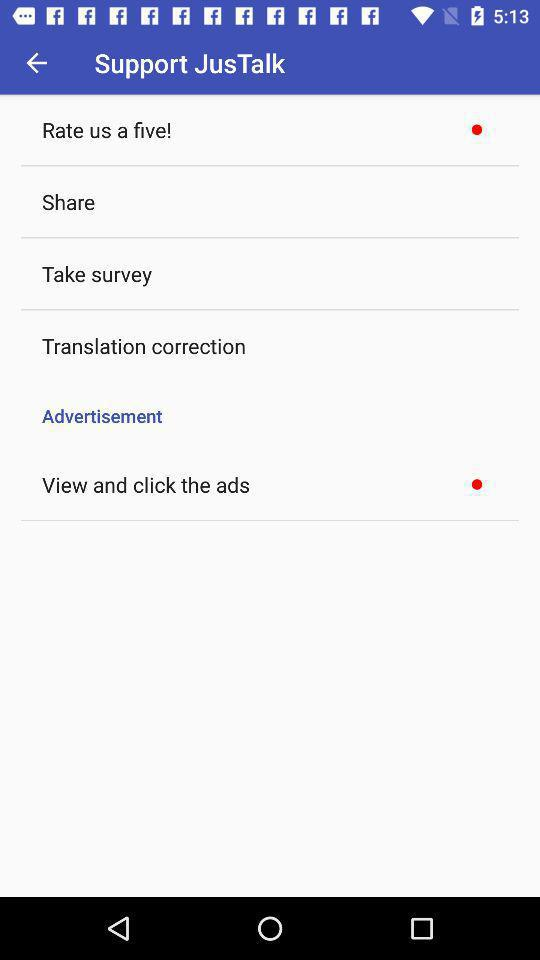What is the name of the application? The name of the application is "JusTalk". 